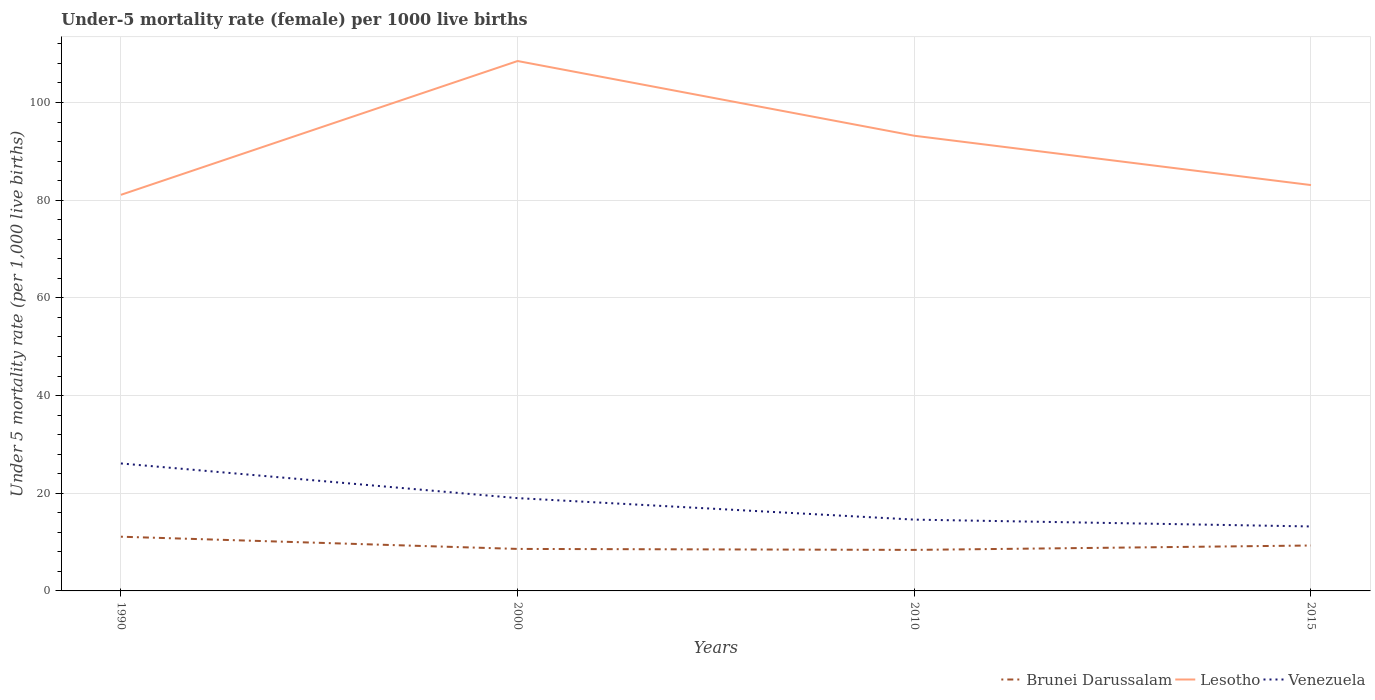How many different coloured lines are there?
Offer a terse response. 3. Across all years, what is the maximum under-five mortality rate in Lesotho?
Provide a short and direct response. 81.1. What is the total under-five mortality rate in Venezuela in the graph?
Offer a very short reply. 4.4. What is the difference between the highest and the second highest under-five mortality rate in Brunei Darussalam?
Your answer should be very brief. 2.7. How many lines are there?
Keep it short and to the point. 3. How many years are there in the graph?
Your answer should be compact. 4. What is the difference between two consecutive major ticks on the Y-axis?
Provide a succinct answer. 20. Are the values on the major ticks of Y-axis written in scientific E-notation?
Ensure brevity in your answer.  No. Does the graph contain any zero values?
Make the answer very short. No. Does the graph contain grids?
Keep it short and to the point. Yes. Where does the legend appear in the graph?
Provide a succinct answer. Bottom right. What is the title of the graph?
Your answer should be very brief. Under-5 mortality rate (female) per 1000 live births. Does "St. Vincent and the Grenadines" appear as one of the legend labels in the graph?
Your answer should be very brief. No. What is the label or title of the X-axis?
Offer a terse response. Years. What is the label or title of the Y-axis?
Your response must be concise. Under 5 mortality rate (per 1,0 live births). What is the Under 5 mortality rate (per 1,000 live births) in Brunei Darussalam in 1990?
Provide a short and direct response. 11.1. What is the Under 5 mortality rate (per 1,000 live births) of Lesotho in 1990?
Make the answer very short. 81.1. What is the Under 5 mortality rate (per 1,000 live births) of Venezuela in 1990?
Your answer should be very brief. 26.1. What is the Under 5 mortality rate (per 1,000 live births) in Lesotho in 2000?
Provide a succinct answer. 108.5. What is the Under 5 mortality rate (per 1,000 live births) in Venezuela in 2000?
Offer a terse response. 19. What is the Under 5 mortality rate (per 1,000 live births) in Brunei Darussalam in 2010?
Provide a short and direct response. 8.4. What is the Under 5 mortality rate (per 1,000 live births) in Lesotho in 2010?
Offer a very short reply. 93.2. What is the Under 5 mortality rate (per 1,000 live births) of Venezuela in 2010?
Provide a short and direct response. 14.6. What is the Under 5 mortality rate (per 1,000 live births) in Lesotho in 2015?
Your answer should be very brief. 83.1. What is the Under 5 mortality rate (per 1,000 live births) in Venezuela in 2015?
Give a very brief answer. 13.2. Across all years, what is the maximum Under 5 mortality rate (per 1,000 live births) of Brunei Darussalam?
Your answer should be compact. 11.1. Across all years, what is the maximum Under 5 mortality rate (per 1,000 live births) in Lesotho?
Make the answer very short. 108.5. Across all years, what is the maximum Under 5 mortality rate (per 1,000 live births) in Venezuela?
Provide a succinct answer. 26.1. Across all years, what is the minimum Under 5 mortality rate (per 1,000 live births) of Lesotho?
Give a very brief answer. 81.1. What is the total Under 5 mortality rate (per 1,000 live births) in Brunei Darussalam in the graph?
Offer a terse response. 37.4. What is the total Under 5 mortality rate (per 1,000 live births) in Lesotho in the graph?
Make the answer very short. 365.9. What is the total Under 5 mortality rate (per 1,000 live births) of Venezuela in the graph?
Give a very brief answer. 72.9. What is the difference between the Under 5 mortality rate (per 1,000 live births) of Brunei Darussalam in 1990 and that in 2000?
Ensure brevity in your answer.  2.5. What is the difference between the Under 5 mortality rate (per 1,000 live births) in Lesotho in 1990 and that in 2000?
Give a very brief answer. -27.4. What is the difference between the Under 5 mortality rate (per 1,000 live births) in Lesotho in 1990 and that in 2010?
Give a very brief answer. -12.1. What is the difference between the Under 5 mortality rate (per 1,000 live births) of Venezuela in 1990 and that in 2010?
Ensure brevity in your answer.  11.5. What is the difference between the Under 5 mortality rate (per 1,000 live births) of Brunei Darussalam in 1990 and that in 2015?
Ensure brevity in your answer.  1.8. What is the difference between the Under 5 mortality rate (per 1,000 live births) in Lesotho in 2000 and that in 2010?
Offer a terse response. 15.3. What is the difference between the Under 5 mortality rate (per 1,000 live births) of Brunei Darussalam in 2000 and that in 2015?
Provide a short and direct response. -0.7. What is the difference between the Under 5 mortality rate (per 1,000 live births) in Lesotho in 2000 and that in 2015?
Offer a very short reply. 25.4. What is the difference between the Under 5 mortality rate (per 1,000 live births) in Venezuela in 2000 and that in 2015?
Keep it short and to the point. 5.8. What is the difference between the Under 5 mortality rate (per 1,000 live births) in Lesotho in 2010 and that in 2015?
Your response must be concise. 10.1. What is the difference between the Under 5 mortality rate (per 1,000 live births) in Venezuela in 2010 and that in 2015?
Offer a very short reply. 1.4. What is the difference between the Under 5 mortality rate (per 1,000 live births) in Brunei Darussalam in 1990 and the Under 5 mortality rate (per 1,000 live births) in Lesotho in 2000?
Your answer should be compact. -97.4. What is the difference between the Under 5 mortality rate (per 1,000 live births) in Lesotho in 1990 and the Under 5 mortality rate (per 1,000 live births) in Venezuela in 2000?
Provide a succinct answer. 62.1. What is the difference between the Under 5 mortality rate (per 1,000 live births) in Brunei Darussalam in 1990 and the Under 5 mortality rate (per 1,000 live births) in Lesotho in 2010?
Ensure brevity in your answer.  -82.1. What is the difference between the Under 5 mortality rate (per 1,000 live births) in Lesotho in 1990 and the Under 5 mortality rate (per 1,000 live births) in Venezuela in 2010?
Make the answer very short. 66.5. What is the difference between the Under 5 mortality rate (per 1,000 live births) in Brunei Darussalam in 1990 and the Under 5 mortality rate (per 1,000 live births) in Lesotho in 2015?
Make the answer very short. -72. What is the difference between the Under 5 mortality rate (per 1,000 live births) in Brunei Darussalam in 1990 and the Under 5 mortality rate (per 1,000 live births) in Venezuela in 2015?
Offer a very short reply. -2.1. What is the difference between the Under 5 mortality rate (per 1,000 live births) in Lesotho in 1990 and the Under 5 mortality rate (per 1,000 live births) in Venezuela in 2015?
Keep it short and to the point. 67.9. What is the difference between the Under 5 mortality rate (per 1,000 live births) in Brunei Darussalam in 2000 and the Under 5 mortality rate (per 1,000 live births) in Lesotho in 2010?
Your answer should be compact. -84.6. What is the difference between the Under 5 mortality rate (per 1,000 live births) of Lesotho in 2000 and the Under 5 mortality rate (per 1,000 live births) of Venezuela in 2010?
Offer a terse response. 93.9. What is the difference between the Under 5 mortality rate (per 1,000 live births) in Brunei Darussalam in 2000 and the Under 5 mortality rate (per 1,000 live births) in Lesotho in 2015?
Give a very brief answer. -74.5. What is the difference between the Under 5 mortality rate (per 1,000 live births) of Lesotho in 2000 and the Under 5 mortality rate (per 1,000 live births) of Venezuela in 2015?
Offer a very short reply. 95.3. What is the difference between the Under 5 mortality rate (per 1,000 live births) in Brunei Darussalam in 2010 and the Under 5 mortality rate (per 1,000 live births) in Lesotho in 2015?
Ensure brevity in your answer.  -74.7. What is the difference between the Under 5 mortality rate (per 1,000 live births) in Brunei Darussalam in 2010 and the Under 5 mortality rate (per 1,000 live births) in Venezuela in 2015?
Your answer should be very brief. -4.8. What is the average Under 5 mortality rate (per 1,000 live births) in Brunei Darussalam per year?
Give a very brief answer. 9.35. What is the average Under 5 mortality rate (per 1,000 live births) in Lesotho per year?
Provide a short and direct response. 91.47. What is the average Under 5 mortality rate (per 1,000 live births) in Venezuela per year?
Ensure brevity in your answer.  18.23. In the year 1990, what is the difference between the Under 5 mortality rate (per 1,000 live births) in Brunei Darussalam and Under 5 mortality rate (per 1,000 live births) in Lesotho?
Give a very brief answer. -70. In the year 1990, what is the difference between the Under 5 mortality rate (per 1,000 live births) in Brunei Darussalam and Under 5 mortality rate (per 1,000 live births) in Venezuela?
Offer a terse response. -15. In the year 2000, what is the difference between the Under 5 mortality rate (per 1,000 live births) of Brunei Darussalam and Under 5 mortality rate (per 1,000 live births) of Lesotho?
Provide a short and direct response. -99.9. In the year 2000, what is the difference between the Under 5 mortality rate (per 1,000 live births) in Lesotho and Under 5 mortality rate (per 1,000 live births) in Venezuela?
Ensure brevity in your answer.  89.5. In the year 2010, what is the difference between the Under 5 mortality rate (per 1,000 live births) of Brunei Darussalam and Under 5 mortality rate (per 1,000 live births) of Lesotho?
Offer a terse response. -84.8. In the year 2010, what is the difference between the Under 5 mortality rate (per 1,000 live births) of Lesotho and Under 5 mortality rate (per 1,000 live births) of Venezuela?
Offer a terse response. 78.6. In the year 2015, what is the difference between the Under 5 mortality rate (per 1,000 live births) in Brunei Darussalam and Under 5 mortality rate (per 1,000 live births) in Lesotho?
Your response must be concise. -73.8. In the year 2015, what is the difference between the Under 5 mortality rate (per 1,000 live births) of Brunei Darussalam and Under 5 mortality rate (per 1,000 live births) of Venezuela?
Offer a terse response. -3.9. In the year 2015, what is the difference between the Under 5 mortality rate (per 1,000 live births) of Lesotho and Under 5 mortality rate (per 1,000 live births) of Venezuela?
Your answer should be very brief. 69.9. What is the ratio of the Under 5 mortality rate (per 1,000 live births) in Brunei Darussalam in 1990 to that in 2000?
Keep it short and to the point. 1.29. What is the ratio of the Under 5 mortality rate (per 1,000 live births) of Lesotho in 1990 to that in 2000?
Give a very brief answer. 0.75. What is the ratio of the Under 5 mortality rate (per 1,000 live births) of Venezuela in 1990 to that in 2000?
Make the answer very short. 1.37. What is the ratio of the Under 5 mortality rate (per 1,000 live births) in Brunei Darussalam in 1990 to that in 2010?
Your answer should be very brief. 1.32. What is the ratio of the Under 5 mortality rate (per 1,000 live births) of Lesotho in 1990 to that in 2010?
Offer a terse response. 0.87. What is the ratio of the Under 5 mortality rate (per 1,000 live births) of Venezuela in 1990 to that in 2010?
Your answer should be compact. 1.79. What is the ratio of the Under 5 mortality rate (per 1,000 live births) of Brunei Darussalam in 1990 to that in 2015?
Make the answer very short. 1.19. What is the ratio of the Under 5 mortality rate (per 1,000 live births) in Lesotho in 1990 to that in 2015?
Your answer should be compact. 0.98. What is the ratio of the Under 5 mortality rate (per 1,000 live births) of Venezuela in 1990 to that in 2015?
Your answer should be very brief. 1.98. What is the ratio of the Under 5 mortality rate (per 1,000 live births) in Brunei Darussalam in 2000 to that in 2010?
Provide a succinct answer. 1.02. What is the ratio of the Under 5 mortality rate (per 1,000 live births) of Lesotho in 2000 to that in 2010?
Offer a terse response. 1.16. What is the ratio of the Under 5 mortality rate (per 1,000 live births) of Venezuela in 2000 to that in 2010?
Give a very brief answer. 1.3. What is the ratio of the Under 5 mortality rate (per 1,000 live births) of Brunei Darussalam in 2000 to that in 2015?
Your response must be concise. 0.92. What is the ratio of the Under 5 mortality rate (per 1,000 live births) of Lesotho in 2000 to that in 2015?
Offer a very short reply. 1.31. What is the ratio of the Under 5 mortality rate (per 1,000 live births) in Venezuela in 2000 to that in 2015?
Make the answer very short. 1.44. What is the ratio of the Under 5 mortality rate (per 1,000 live births) of Brunei Darussalam in 2010 to that in 2015?
Make the answer very short. 0.9. What is the ratio of the Under 5 mortality rate (per 1,000 live births) of Lesotho in 2010 to that in 2015?
Your answer should be compact. 1.12. What is the ratio of the Under 5 mortality rate (per 1,000 live births) in Venezuela in 2010 to that in 2015?
Provide a short and direct response. 1.11. What is the difference between the highest and the lowest Under 5 mortality rate (per 1,000 live births) of Brunei Darussalam?
Provide a short and direct response. 2.7. What is the difference between the highest and the lowest Under 5 mortality rate (per 1,000 live births) of Lesotho?
Offer a very short reply. 27.4. What is the difference between the highest and the lowest Under 5 mortality rate (per 1,000 live births) in Venezuela?
Ensure brevity in your answer.  12.9. 